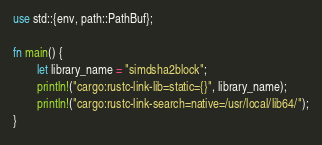<code> <loc_0><loc_0><loc_500><loc_500><_Rust_>use std::{env, path::PathBuf};

fn main() {
        let library_name = "simdsha2block";
        println!("cargo:rustc-link-lib=static={}", library_name);
        println!("cargo:rustc-link-search=native=/usr/local/lib64/");
}

</code> 